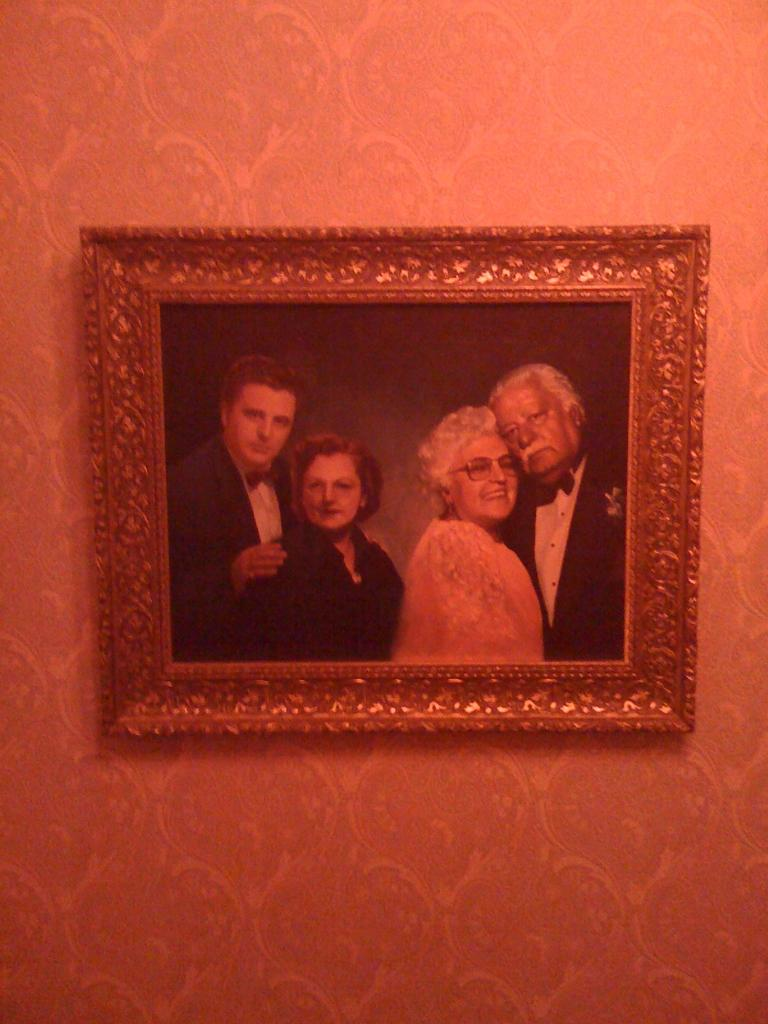What is hanging on the wall in the image? There is a photo frame on the wall. What is inside the photo frame? The photo frame contains a picture of four persons. Is the photo frame sinking in quicksand in the image? No, the photo frame is hanging on the wall, and there is no quicksand present in the image. How many women are in the picture inside the photo frame? The provided facts do not specify the gender of the persons in the picture, so we cannot determine the number of women in the image. 